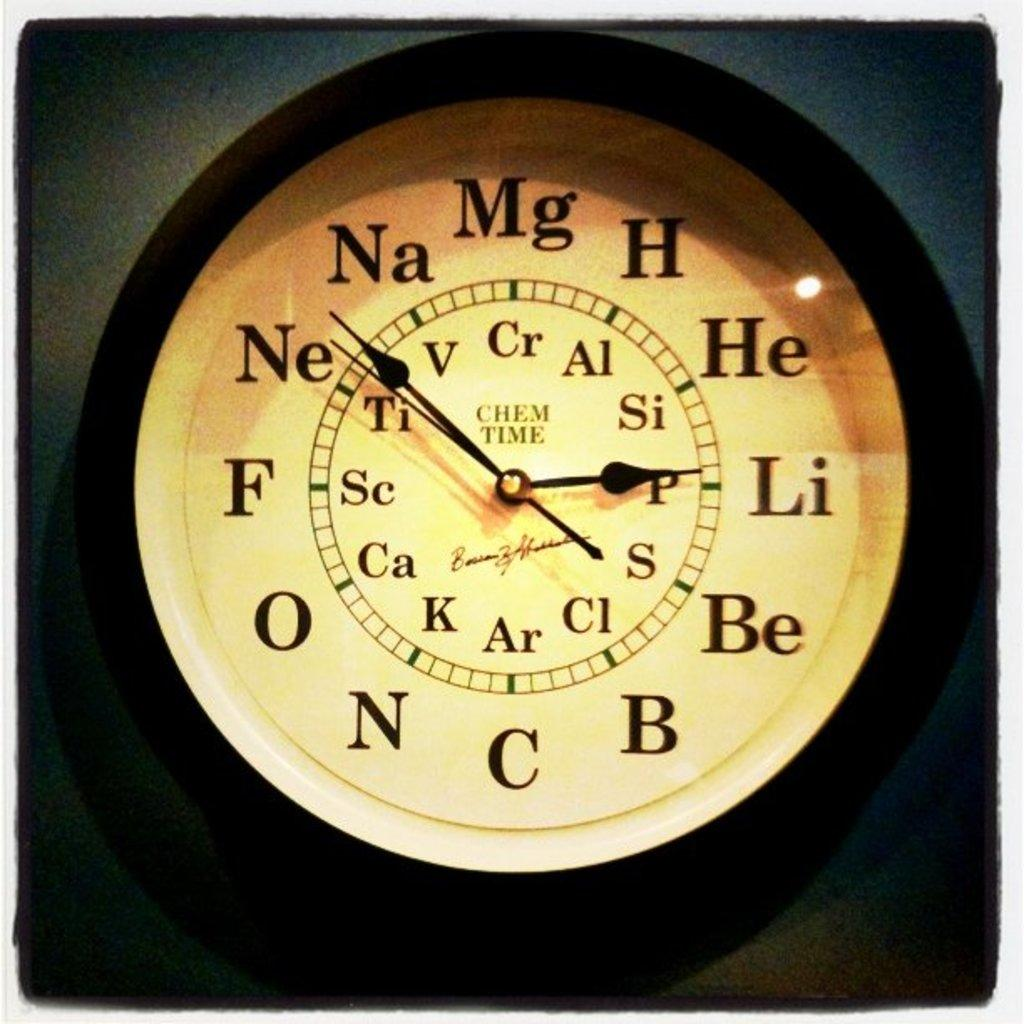What is the main object in the middle of the image? There is a clock in the middle of the image. What features does the clock have? The clock has hour, minute, and second hands. Are there any additional elements on the clock? Yes, there are letters on the clock. How is the clock protected? The clock is covered with a glass. What can be observed about the background of the image? The background of the image is dark in color. How does the clock's wealth affect the trail of shock in the image? There is no mention of wealth, trail, or shock in the image. The image only features a clock with specific details and a dark background. 